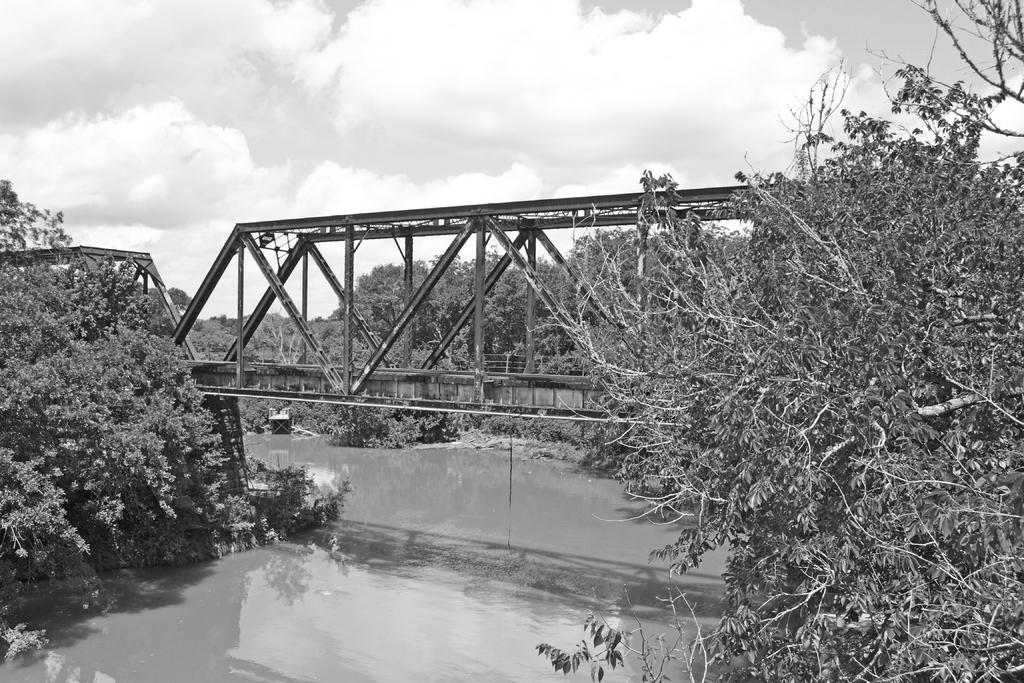What type of vegetation can be seen in the image? There are trees in the image. What structure is located in the middle of the image? There is a bridge in the middle of the image. What body of water is present at the bottom of the image? There is a canal at the bottom of the image. What can be seen in the sky in the image? There are clouds in the sky. Where is the jewel hidden in the image? There is no mention of a jewel in the image, so it cannot be hidden or found within the image. What is causing the bridge to quiver in the image? There is no indication of the bridge quivering or any external force acting upon it in the image. 